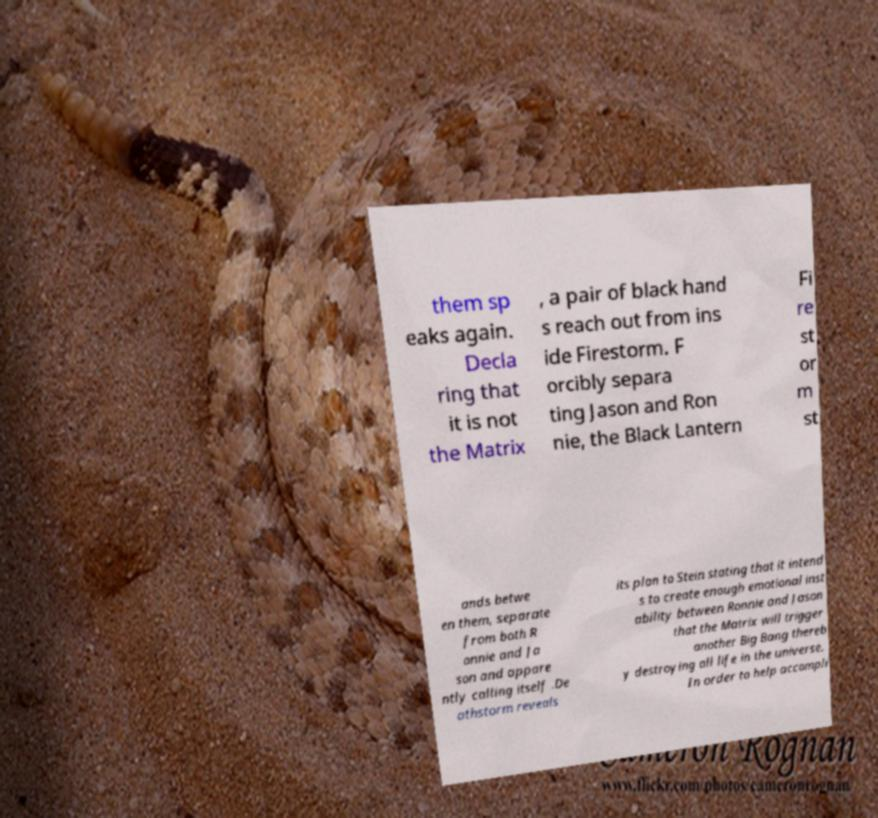Could you extract and type out the text from this image? them sp eaks again. Decla ring that it is not the Matrix , a pair of black hand s reach out from ins ide Firestorm. F orcibly separa ting Jason and Ron nie, the Black Lantern Fi re st or m st ands betwe en them, separate from both R onnie and Ja son and appare ntly calling itself .De athstorm reveals its plan to Stein stating that it intend s to create enough emotional inst ability between Ronnie and Jason that the Matrix will trigger another Big Bang thereb y destroying all life in the universe. In order to help accompli 